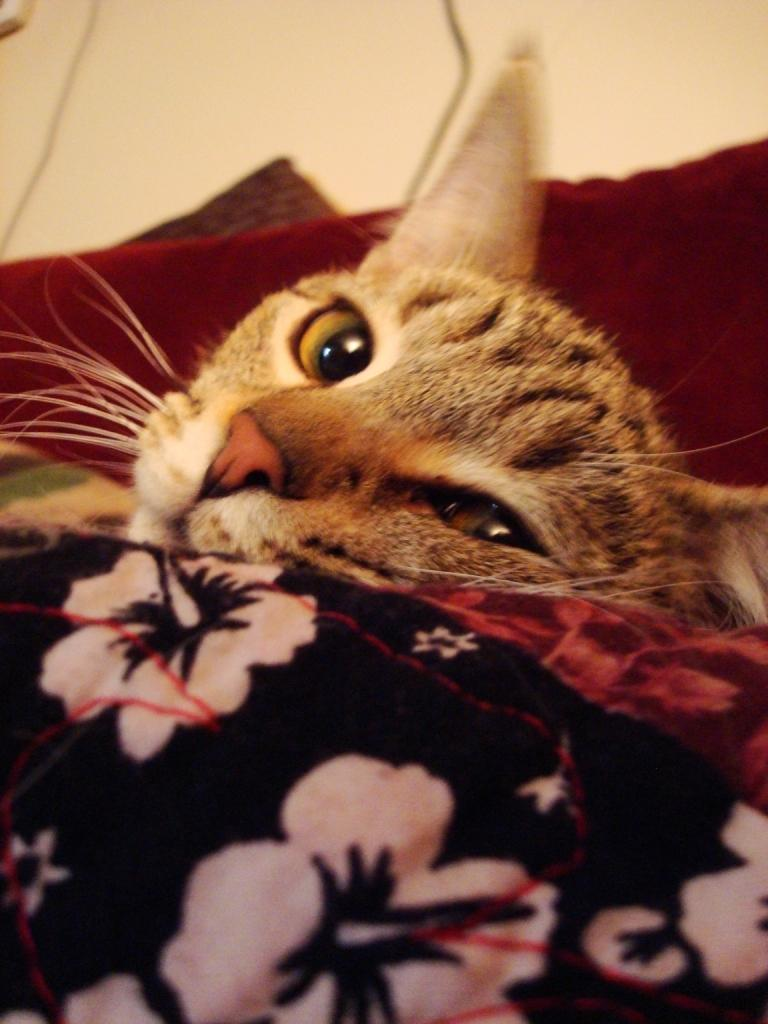What type of animal is in the image? There is a cat in the image. What else can be seen in the image besides the cat? There are clothes in the image. What can be seen in the background of the image? There is a surface visible in the background of the image. What is the value of the company that the women are discussing in the image? There is no mention of a company or women in the image; it only features a cat and clothes. 